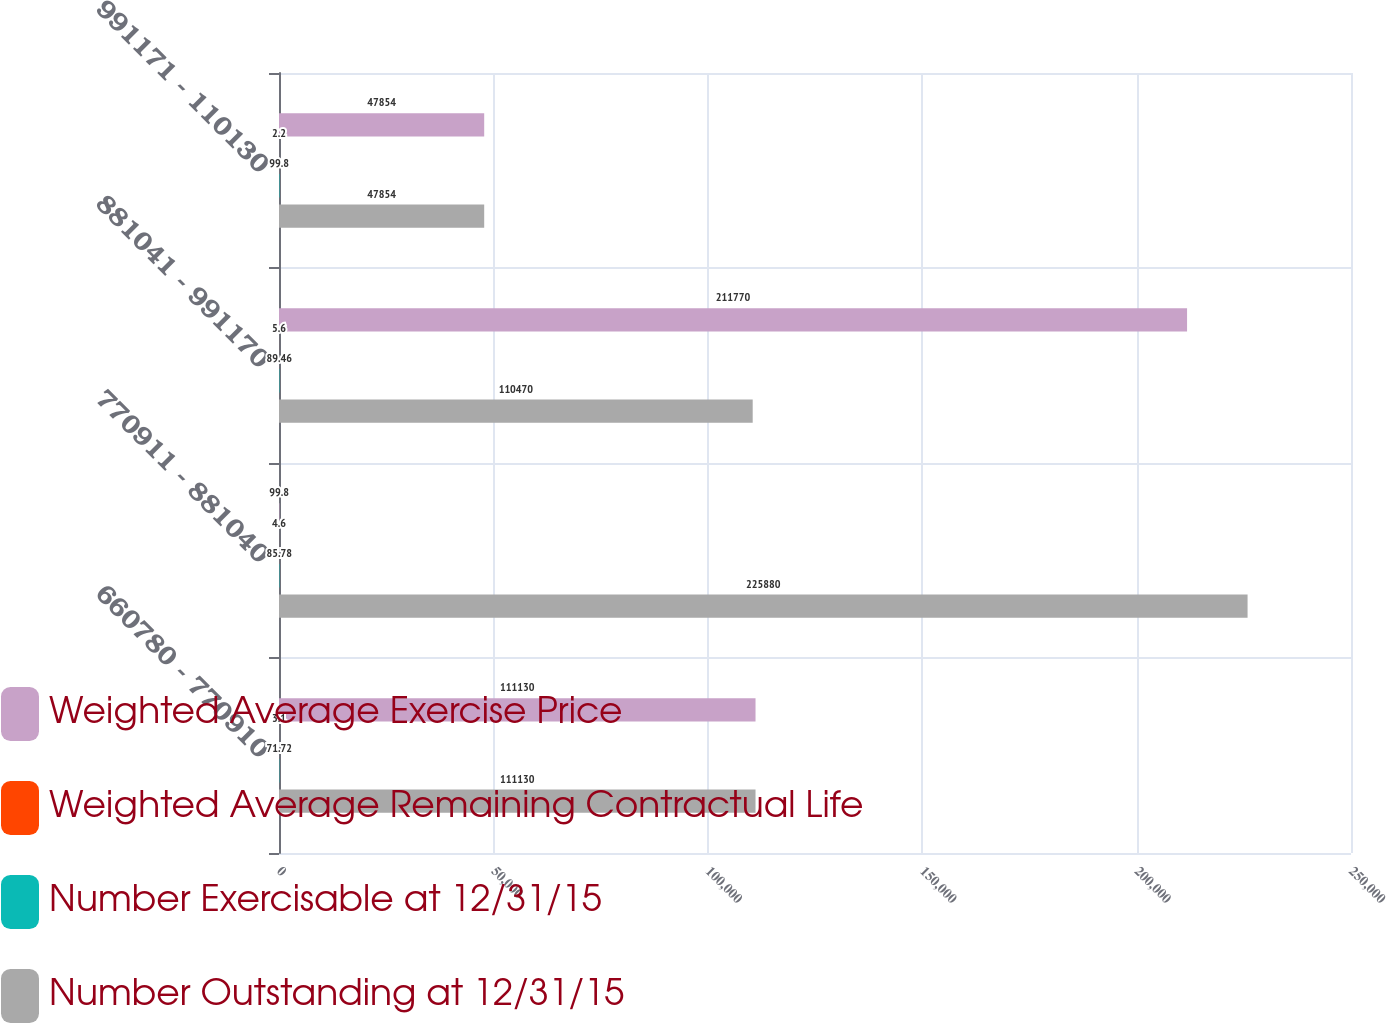<chart> <loc_0><loc_0><loc_500><loc_500><stacked_bar_chart><ecel><fcel>660780 - 770910<fcel>770911 - 881040<fcel>881041 - 991170<fcel>991171 - 110130<nl><fcel>Weighted Average Exercise Price<fcel>111130<fcel>99.8<fcel>211770<fcel>47854<nl><fcel>Weighted Average Remaining Contractual Life<fcel>3.1<fcel>4.6<fcel>5.6<fcel>2.2<nl><fcel>Number Exercisable at 12/31/15<fcel>71.72<fcel>85.78<fcel>89.46<fcel>99.8<nl><fcel>Number Outstanding at 12/31/15<fcel>111130<fcel>225880<fcel>110470<fcel>47854<nl></chart> 